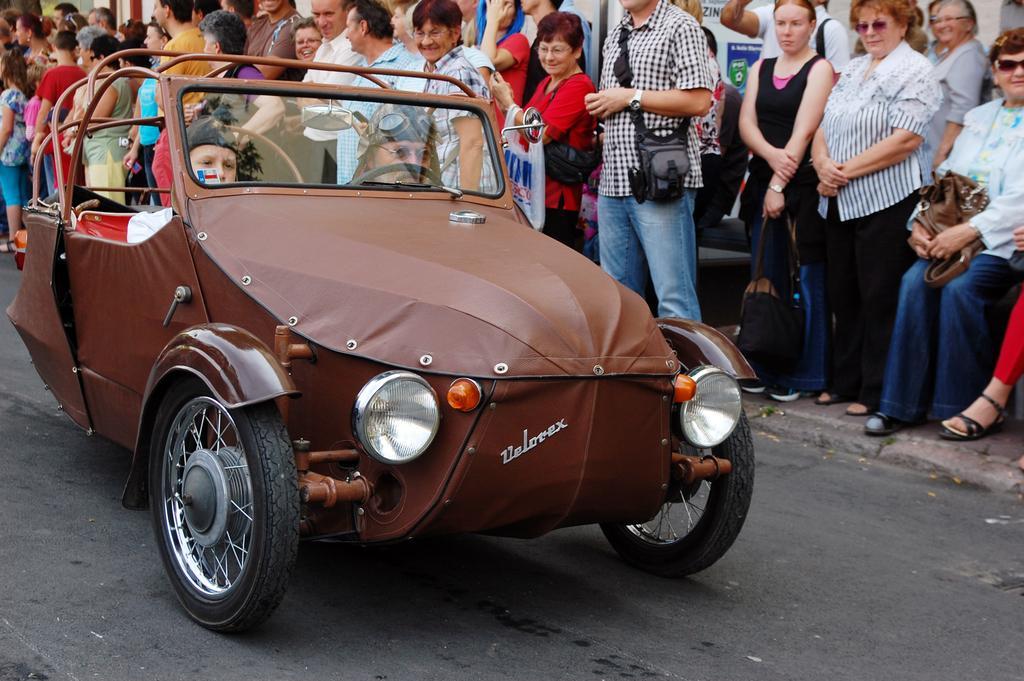Could you give a brief overview of what you see in this image? there is a road in which people are riding vehicle some people are watching them 